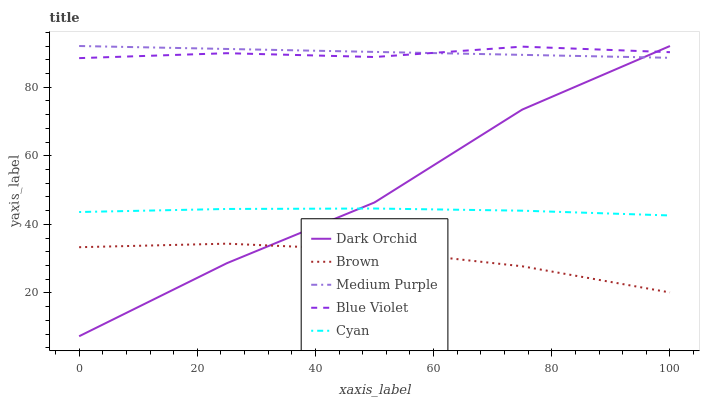Does Brown have the minimum area under the curve?
Answer yes or no. Yes. Does Medium Purple have the maximum area under the curve?
Answer yes or no. Yes. Does Blue Violet have the minimum area under the curve?
Answer yes or no. No. Does Blue Violet have the maximum area under the curve?
Answer yes or no. No. Is Medium Purple the smoothest?
Answer yes or no. Yes. Is Dark Orchid the roughest?
Answer yes or no. Yes. Is Brown the smoothest?
Answer yes or no. No. Is Brown the roughest?
Answer yes or no. No. Does Dark Orchid have the lowest value?
Answer yes or no. Yes. Does Brown have the lowest value?
Answer yes or no. No. Does Dark Orchid have the highest value?
Answer yes or no. Yes. Does Blue Violet have the highest value?
Answer yes or no. No. Is Brown less than Blue Violet?
Answer yes or no. Yes. Is Cyan greater than Brown?
Answer yes or no. Yes. Does Blue Violet intersect Dark Orchid?
Answer yes or no. Yes. Is Blue Violet less than Dark Orchid?
Answer yes or no. No. Is Blue Violet greater than Dark Orchid?
Answer yes or no. No. Does Brown intersect Blue Violet?
Answer yes or no. No. 